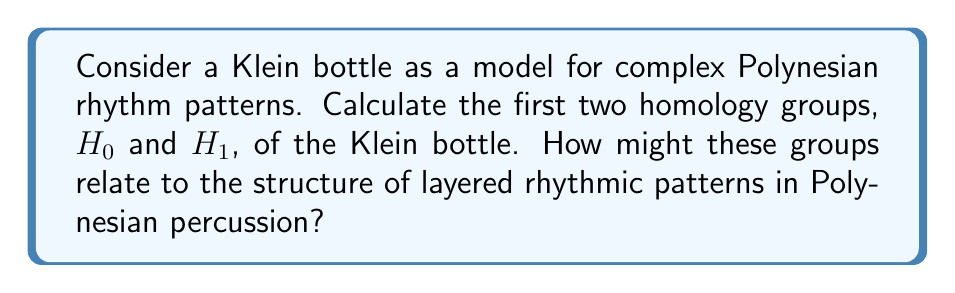Teach me how to tackle this problem. To analyze the homology groups of a Klein bottle and relate them to complex rhythm patterns, let's follow these steps:

1) First, recall that a Klein bottle is a non-orientable surface that can be constructed by gluing the edges of a square in a specific way.

2) The homology groups of a Klein bottle are:
   $H_0(\text{Klein bottle}) \cong \mathbb{Z}$
   $H_1(\text{Klein bottle}) \cong \mathbb{Z} \oplus \mathbb{Z}_2$
   $H_2(\text{Klein bottle}) \cong 0$

3) Let's focus on $H_0$ and $H_1$:

   $H_0 \cong \mathbb{Z}$ represents the number of connected components. The Klein bottle is connected, so $H_0 \cong \mathbb{Z}$.

   $H_1 \cong \mathbb{Z} \oplus \mathbb{Z}_2$ represents the number of holes or loops in the surface. The $\mathbb{Z}$ component corresponds to a non-torsion element (infinite cyclic group), while $\mathbb{Z}_2$ corresponds to a torsion element (cyclic group of order 2).

4) Relating this to Polynesian rhythm patterns:

   - $H_0 \cong \mathbb{Z}$ could represent the fundamental beat or tempo of the rhythm. Just as the Klein bottle is connected, all elements of the rhythm are connected to this fundamental beat.

   - $H_1 \cong \mathbb{Z} \oplus \mathbb{Z}_2$ could represent two types of rhythmic patterns:
     
     a) The $\mathbb{Z}$ component might represent a continuous, repeating pattern that can cycle indefinitely, like a persistent underlying rhythm.
     
     b) The $\mathbb{Z}_2$ component could represent a binary rhythmic element, such as alternating between two different drum sounds or accented and unaccented beats.

5) The non-orientability of the Klein bottle could be analogous to the complex interweaving of rhythms in Polynesian percussion, where patterns may seem to "flip" or "invert" in unexpected ways.

This topological perspective provides a novel way to analyze and understand the structure of complex layered rhythms in Polynesian percussion.
Answer: $H_0(\text{Klein bottle}) \cong \mathbb{Z}$
$H_1(\text{Klein bottle}) \cong \mathbb{Z} \oplus \mathbb{Z}_2$

These groups relate to Polynesian percussion rhythms as follows:
- $H_0$ represents the fundamental beat or tempo.
- $H_1$ represents two types of rhythmic patterns:
  a) $\mathbb{Z}$ component: continuous, repeating pattern
  b) $\mathbb{Z}_2$ component: binary rhythmic element 